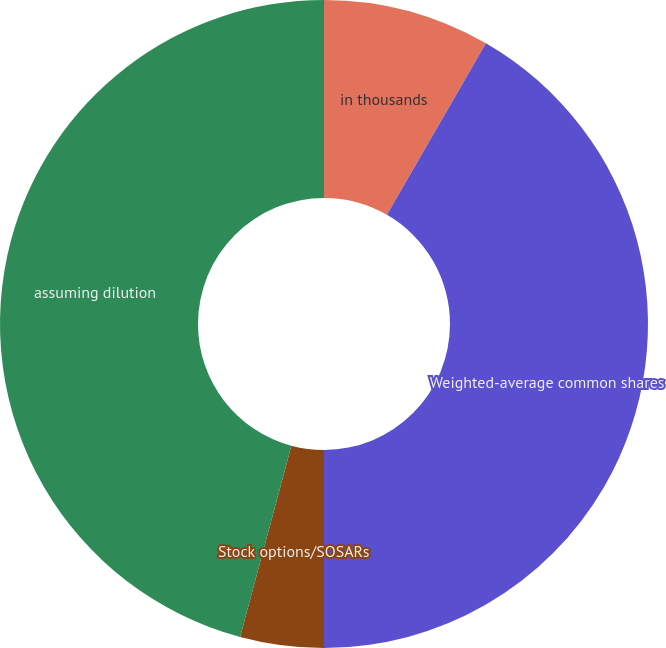Convert chart. <chart><loc_0><loc_0><loc_500><loc_500><pie_chart><fcel>in thousands<fcel>Weighted-average common shares<fcel>Stock options/SOSARs<fcel>Other stock compensation plans<fcel>assuming dilution<nl><fcel>8.33%<fcel>41.67%<fcel>4.17%<fcel>0.0%<fcel>45.83%<nl></chart> 